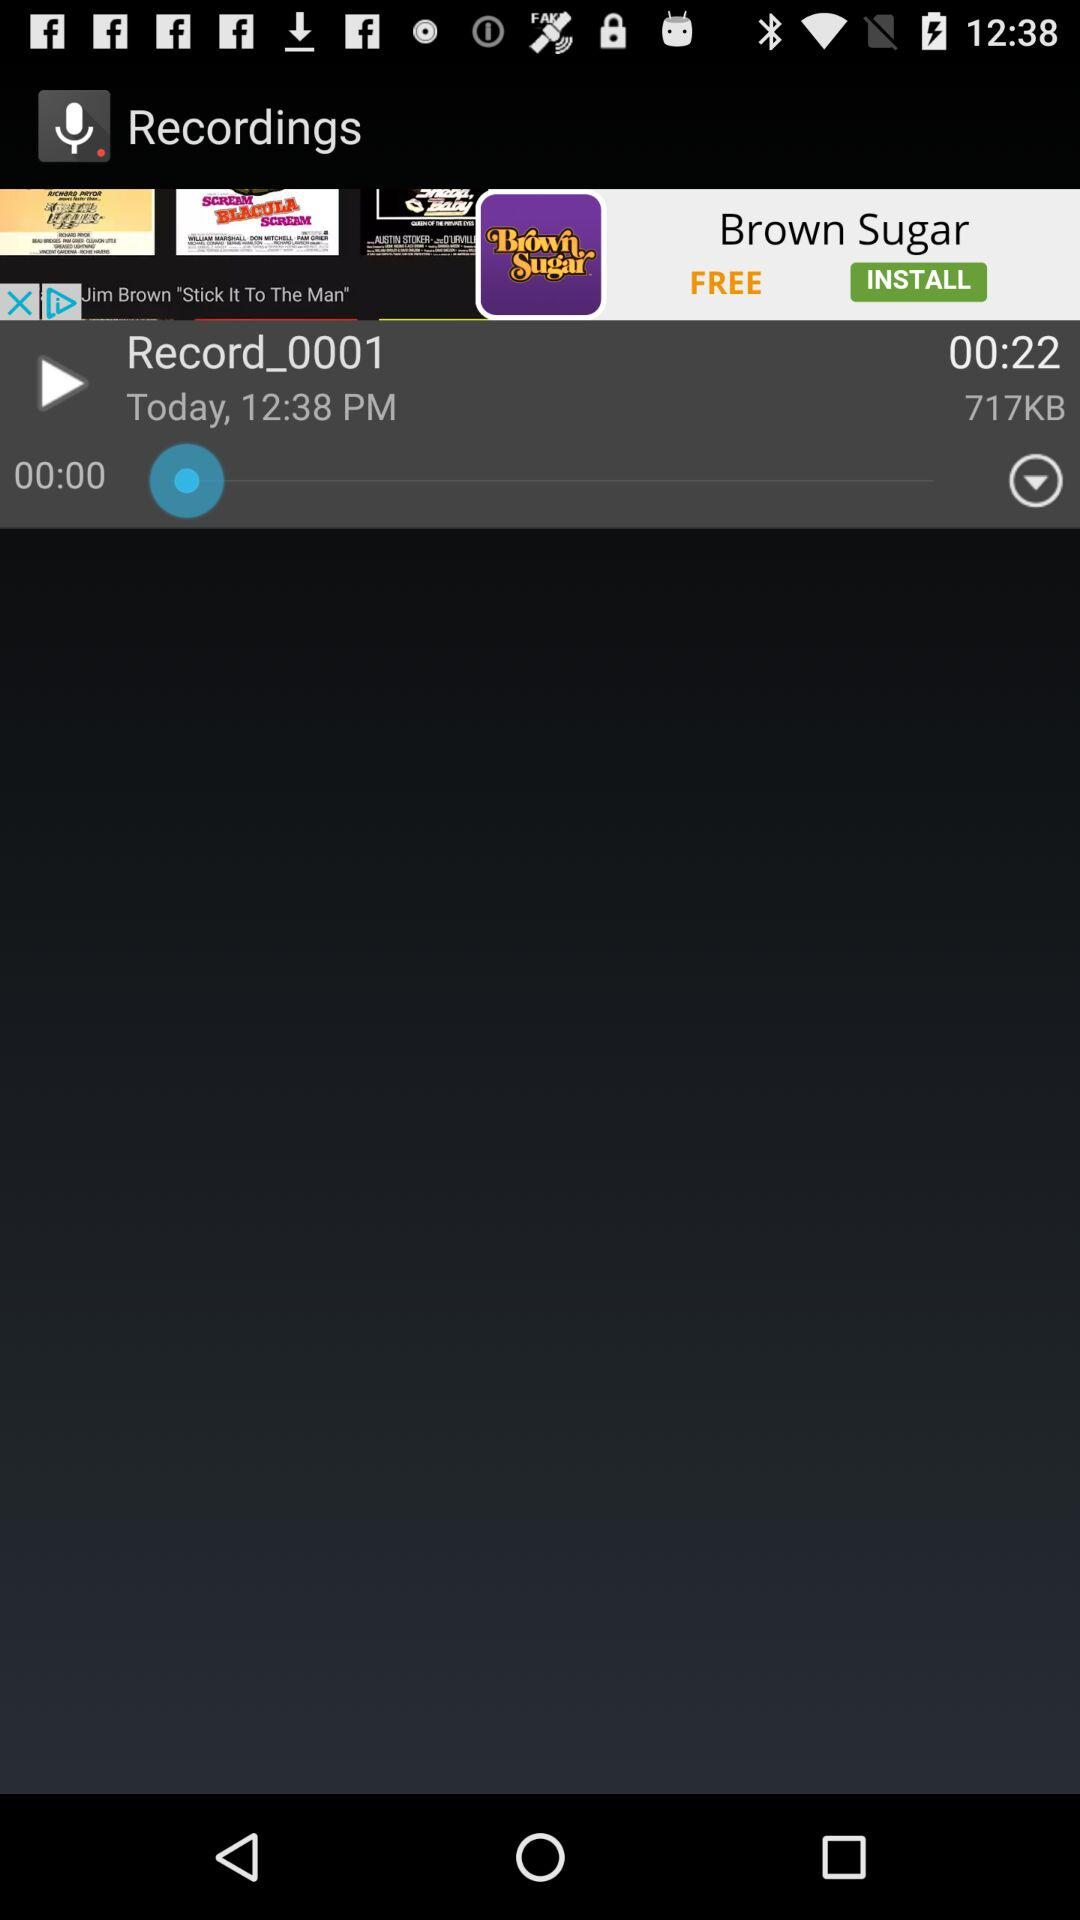What is the total duration of the recording? The total duration of the recording is 22 seconds. 